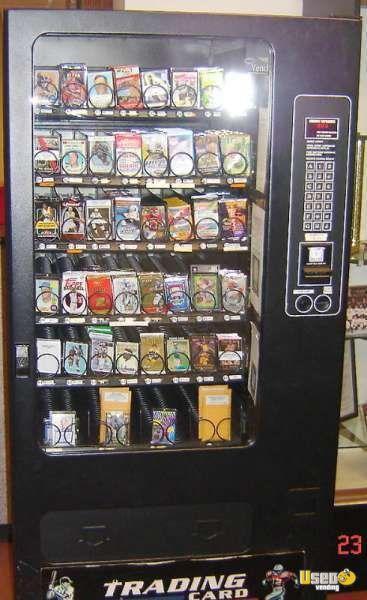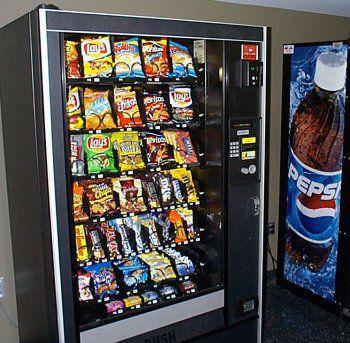The first image is the image on the left, the second image is the image on the right. Evaluate the accuracy of this statement regarding the images: "The vending machine on the left has green color on its frame.". Is it true? Answer yes or no. No. 